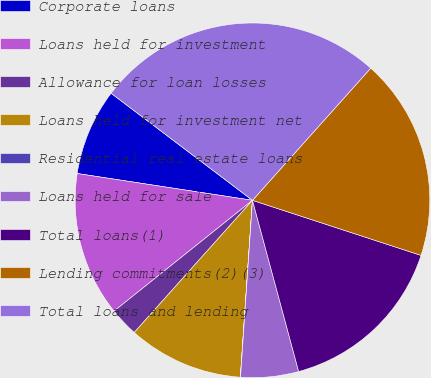Convert chart. <chart><loc_0><loc_0><loc_500><loc_500><pie_chart><fcel>Corporate loans<fcel>Loans held for investment<fcel>Allowance for loan losses<fcel>Loans held for investment net<fcel>Residential real estate loans<fcel>Loans held for sale<fcel>Total loans(1)<fcel>Lending commitments(2)(3)<fcel>Total loans and lending<nl><fcel>7.9%<fcel>13.16%<fcel>2.64%<fcel>10.53%<fcel>0.01%<fcel>5.27%<fcel>15.78%<fcel>18.41%<fcel>26.3%<nl></chart> 